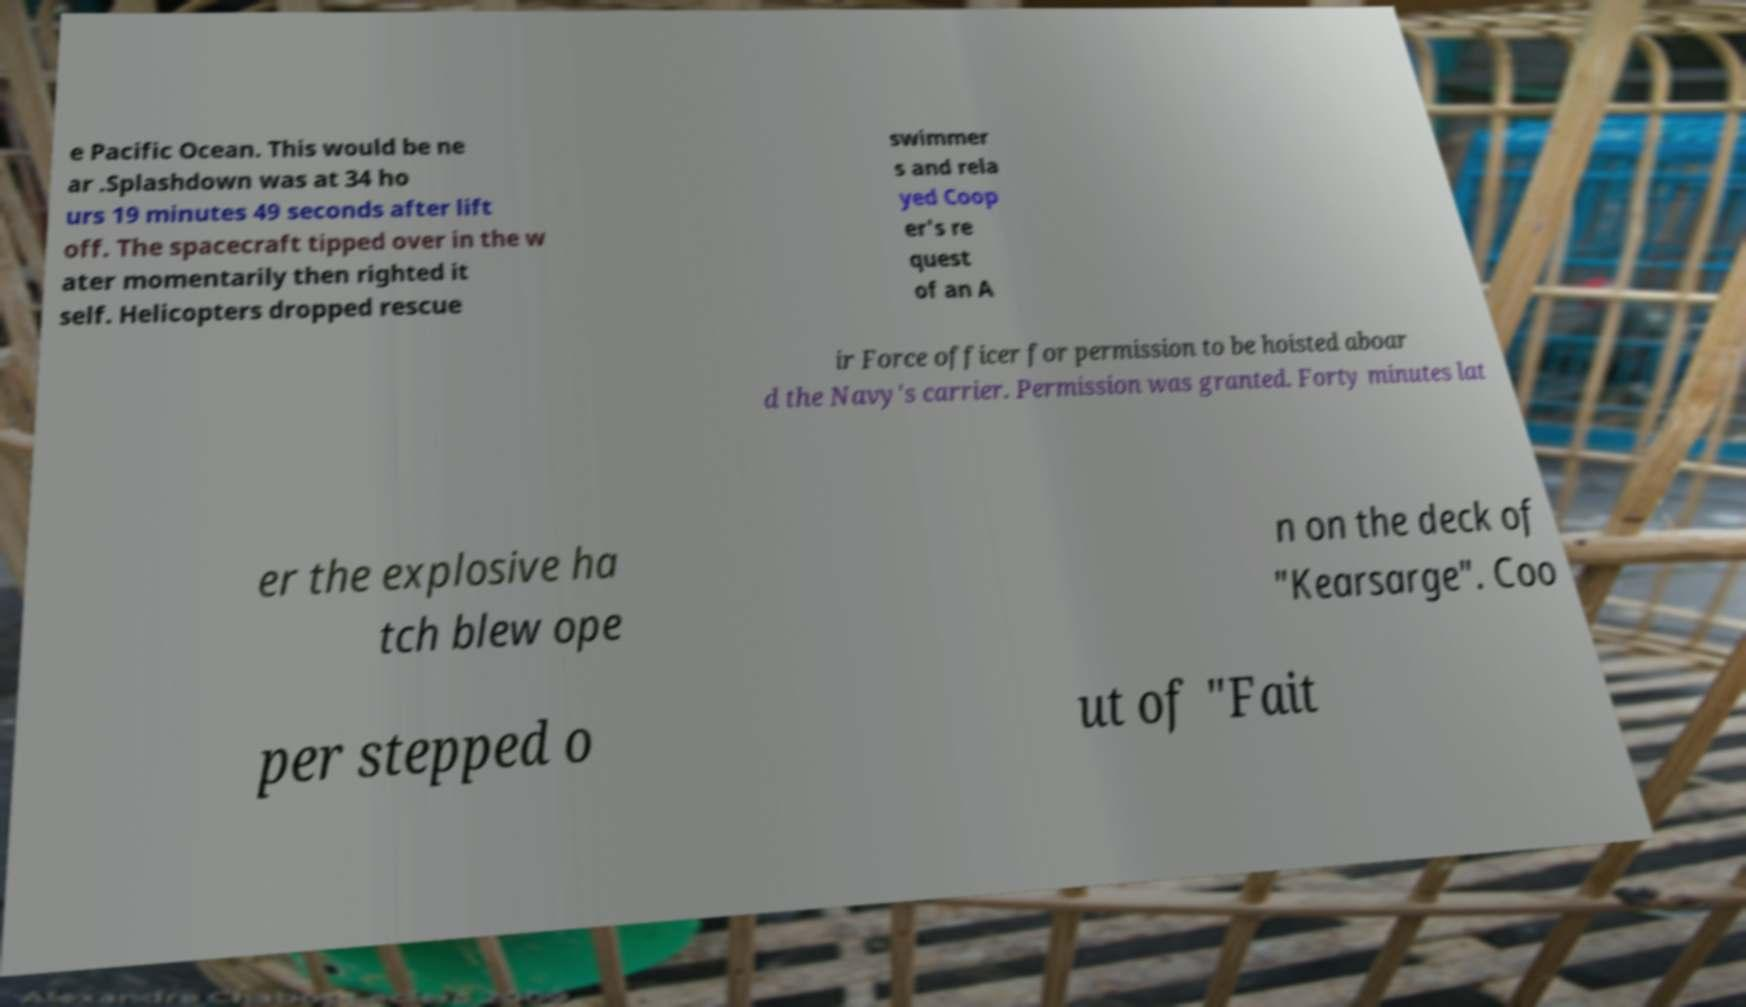Can you accurately transcribe the text from the provided image for me? e Pacific Ocean. This would be ne ar .Splashdown was at 34 ho urs 19 minutes 49 seconds after lift off. The spacecraft tipped over in the w ater momentarily then righted it self. Helicopters dropped rescue swimmer s and rela yed Coop er's re quest of an A ir Force officer for permission to be hoisted aboar d the Navy's carrier. Permission was granted. Forty minutes lat er the explosive ha tch blew ope n on the deck of "Kearsarge". Coo per stepped o ut of "Fait 